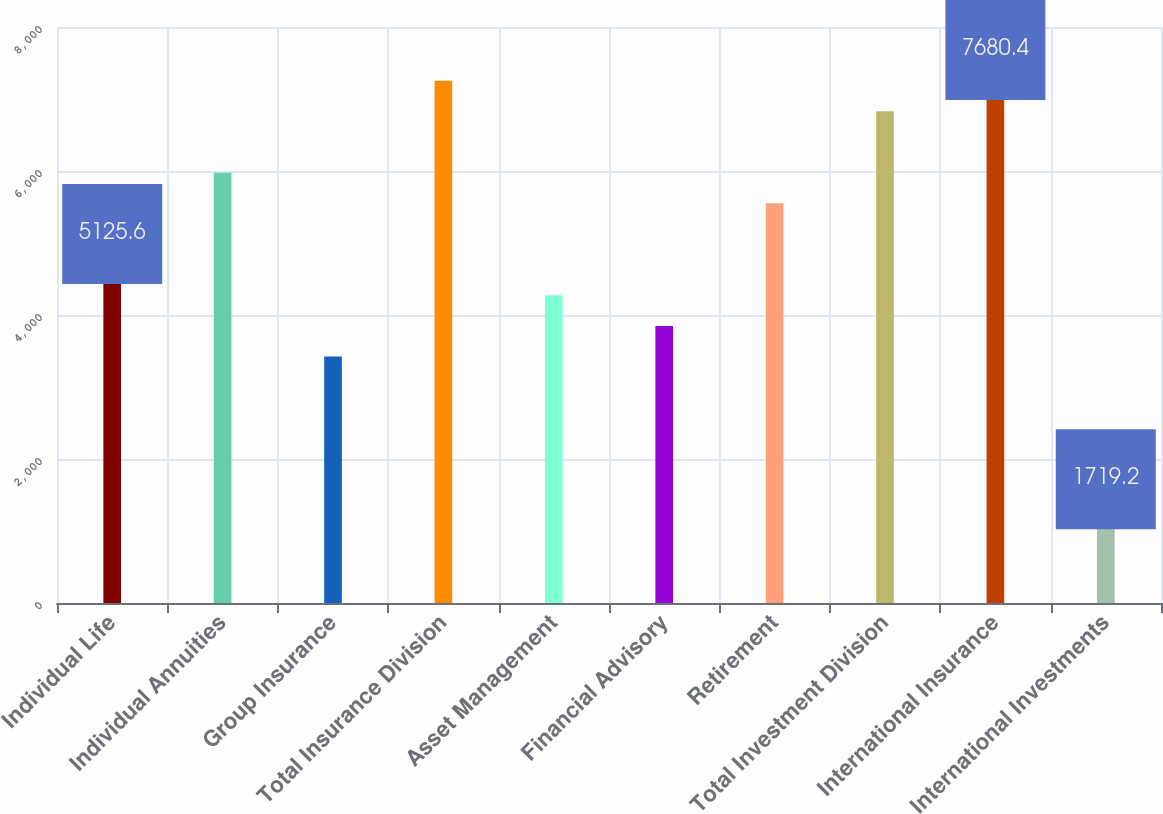Convert chart. <chart><loc_0><loc_0><loc_500><loc_500><bar_chart><fcel>Individual Life<fcel>Individual Annuities<fcel>Group Insurance<fcel>Total Insurance Division<fcel>Asset Management<fcel>Financial Advisory<fcel>Retirement<fcel>Total Investment Division<fcel>International Insurance<fcel>International Investments<nl><fcel>5125.6<fcel>5977.2<fcel>3422.4<fcel>7254.6<fcel>4274<fcel>3848.2<fcel>5551.4<fcel>6828.8<fcel>7680.4<fcel>1719.2<nl></chart> 